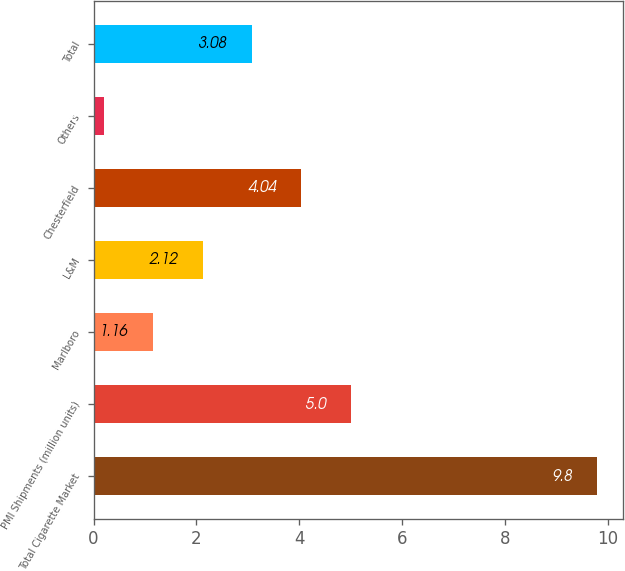<chart> <loc_0><loc_0><loc_500><loc_500><bar_chart><fcel>Total Cigarette Market<fcel>PMI Shipments (million units)<fcel>Marlboro<fcel>L&M<fcel>Chesterfield<fcel>Others<fcel>Total<nl><fcel>9.8<fcel>5<fcel>1.16<fcel>2.12<fcel>4.04<fcel>0.2<fcel>3.08<nl></chart> 